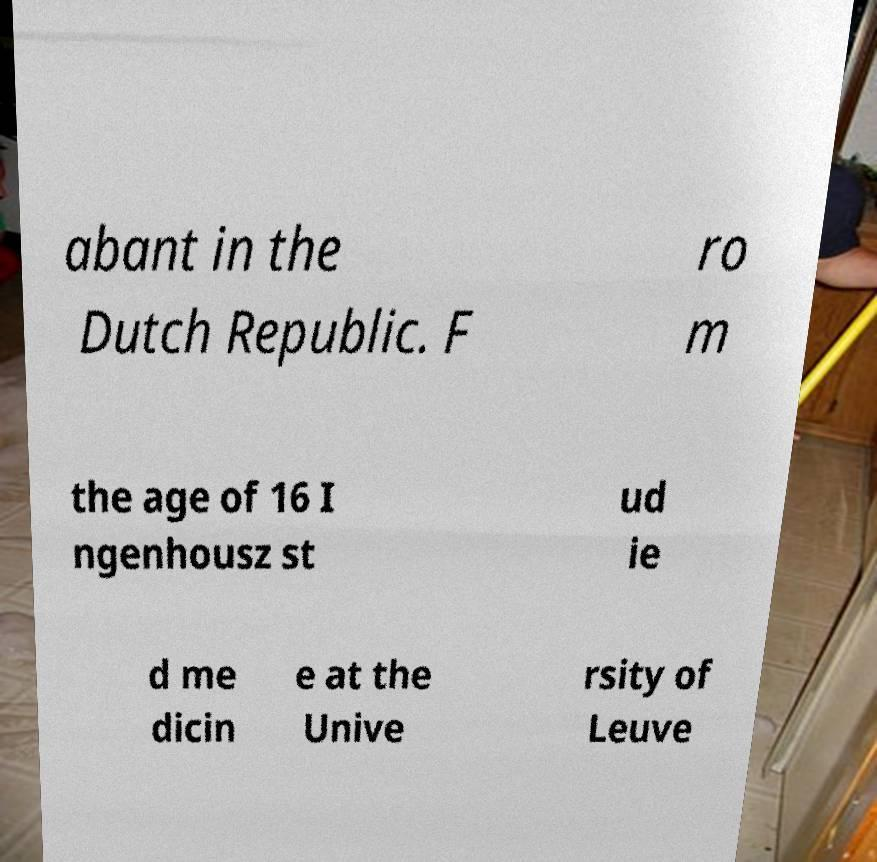There's text embedded in this image that I need extracted. Can you transcribe it verbatim? abant in the Dutch Republic. F ro m the age of 16 I ngenhousz st ud ie d me dicin e at the Unive rsity of Leuve 